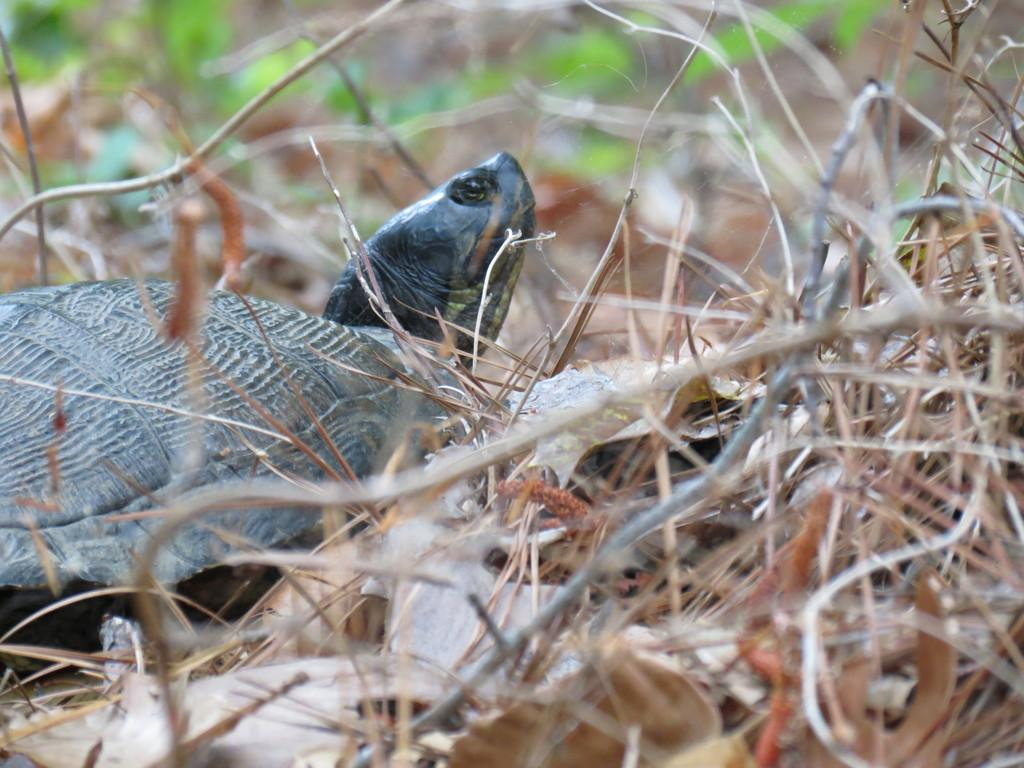What animal is present in the image? There is a tortoise in the image. What type of vegetation can be seen in the foreground of the image? There is grass and twigs in the foreground of the image. Can you describe the top part of the image? The top part of the image is blurred. Is there a lake visible in the background of the image? There is no lake present in the image. How does the tortoise handle the rainstorm in the image? There is no rainstorm depicted in the image, so it is not possible to determine how the tortoise would handle it. 